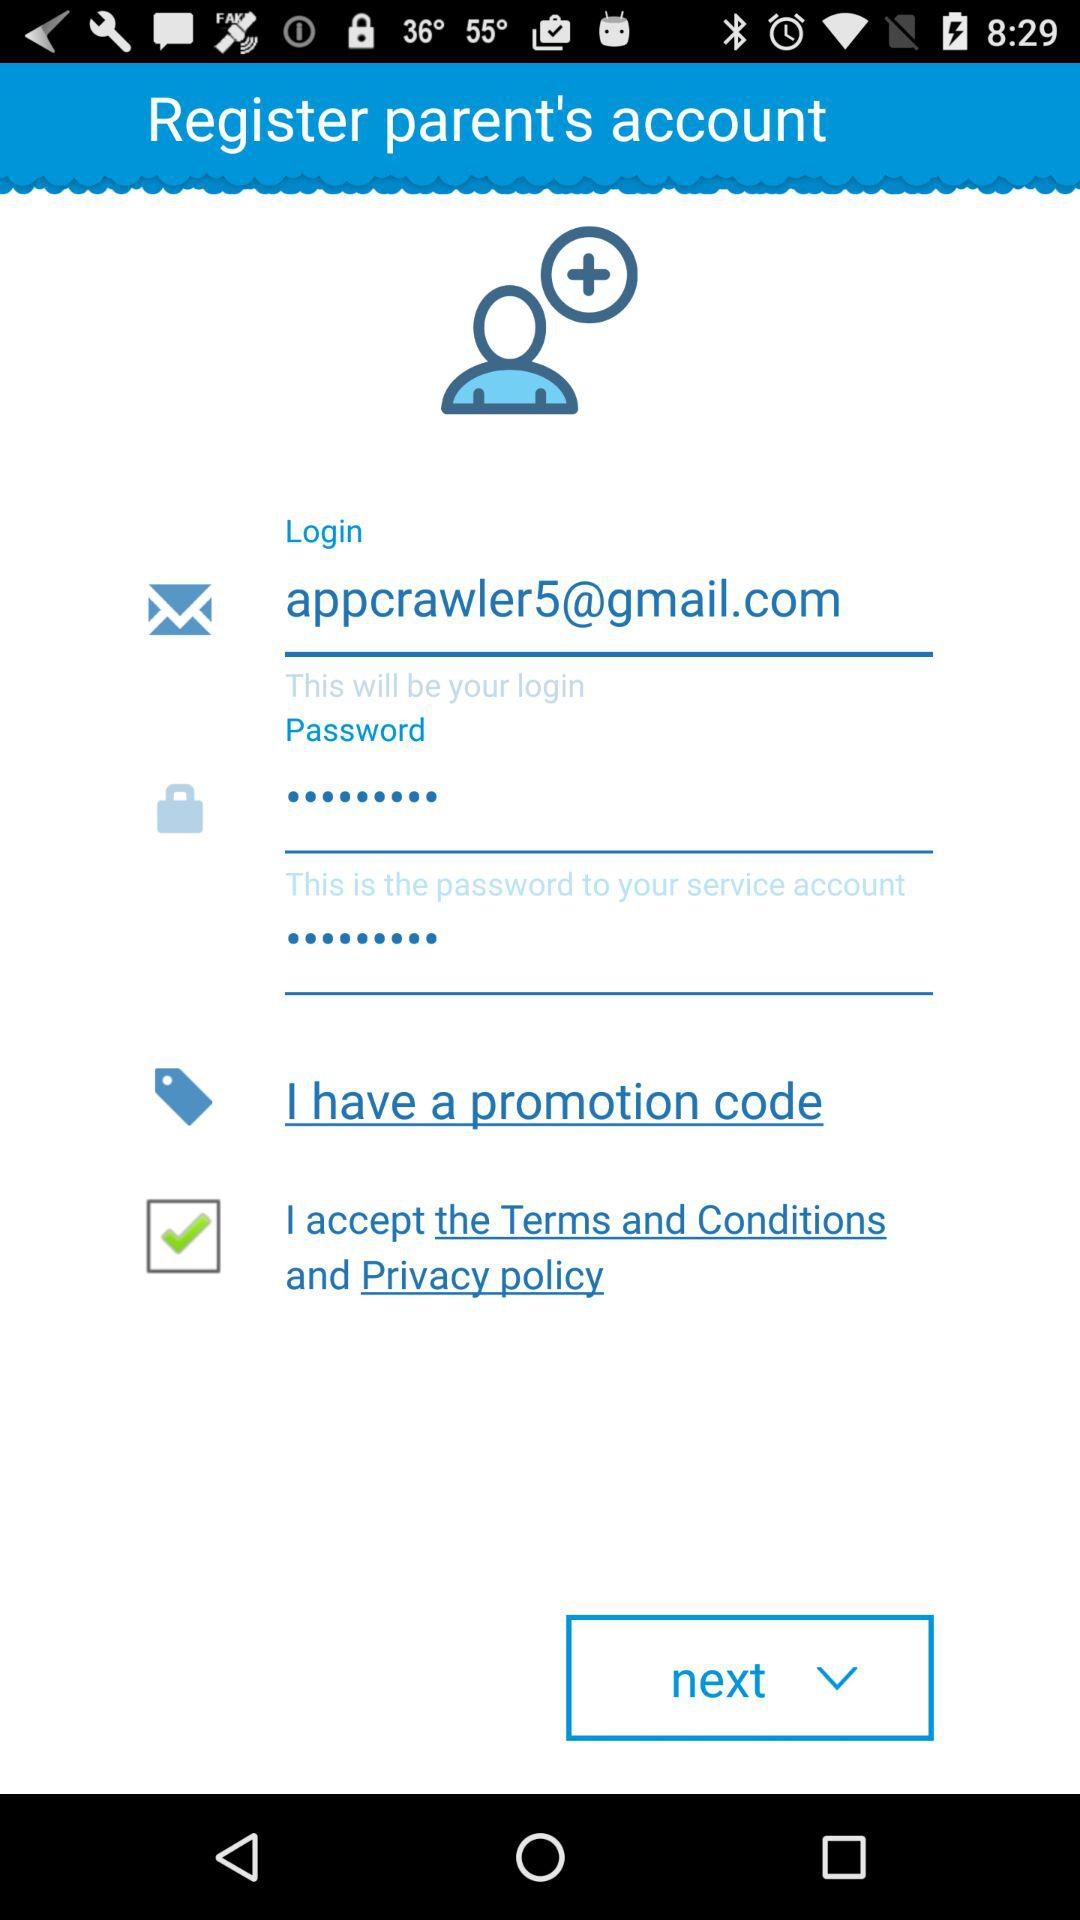What is the email address? The email address is appcrawler5@gmail.com. 